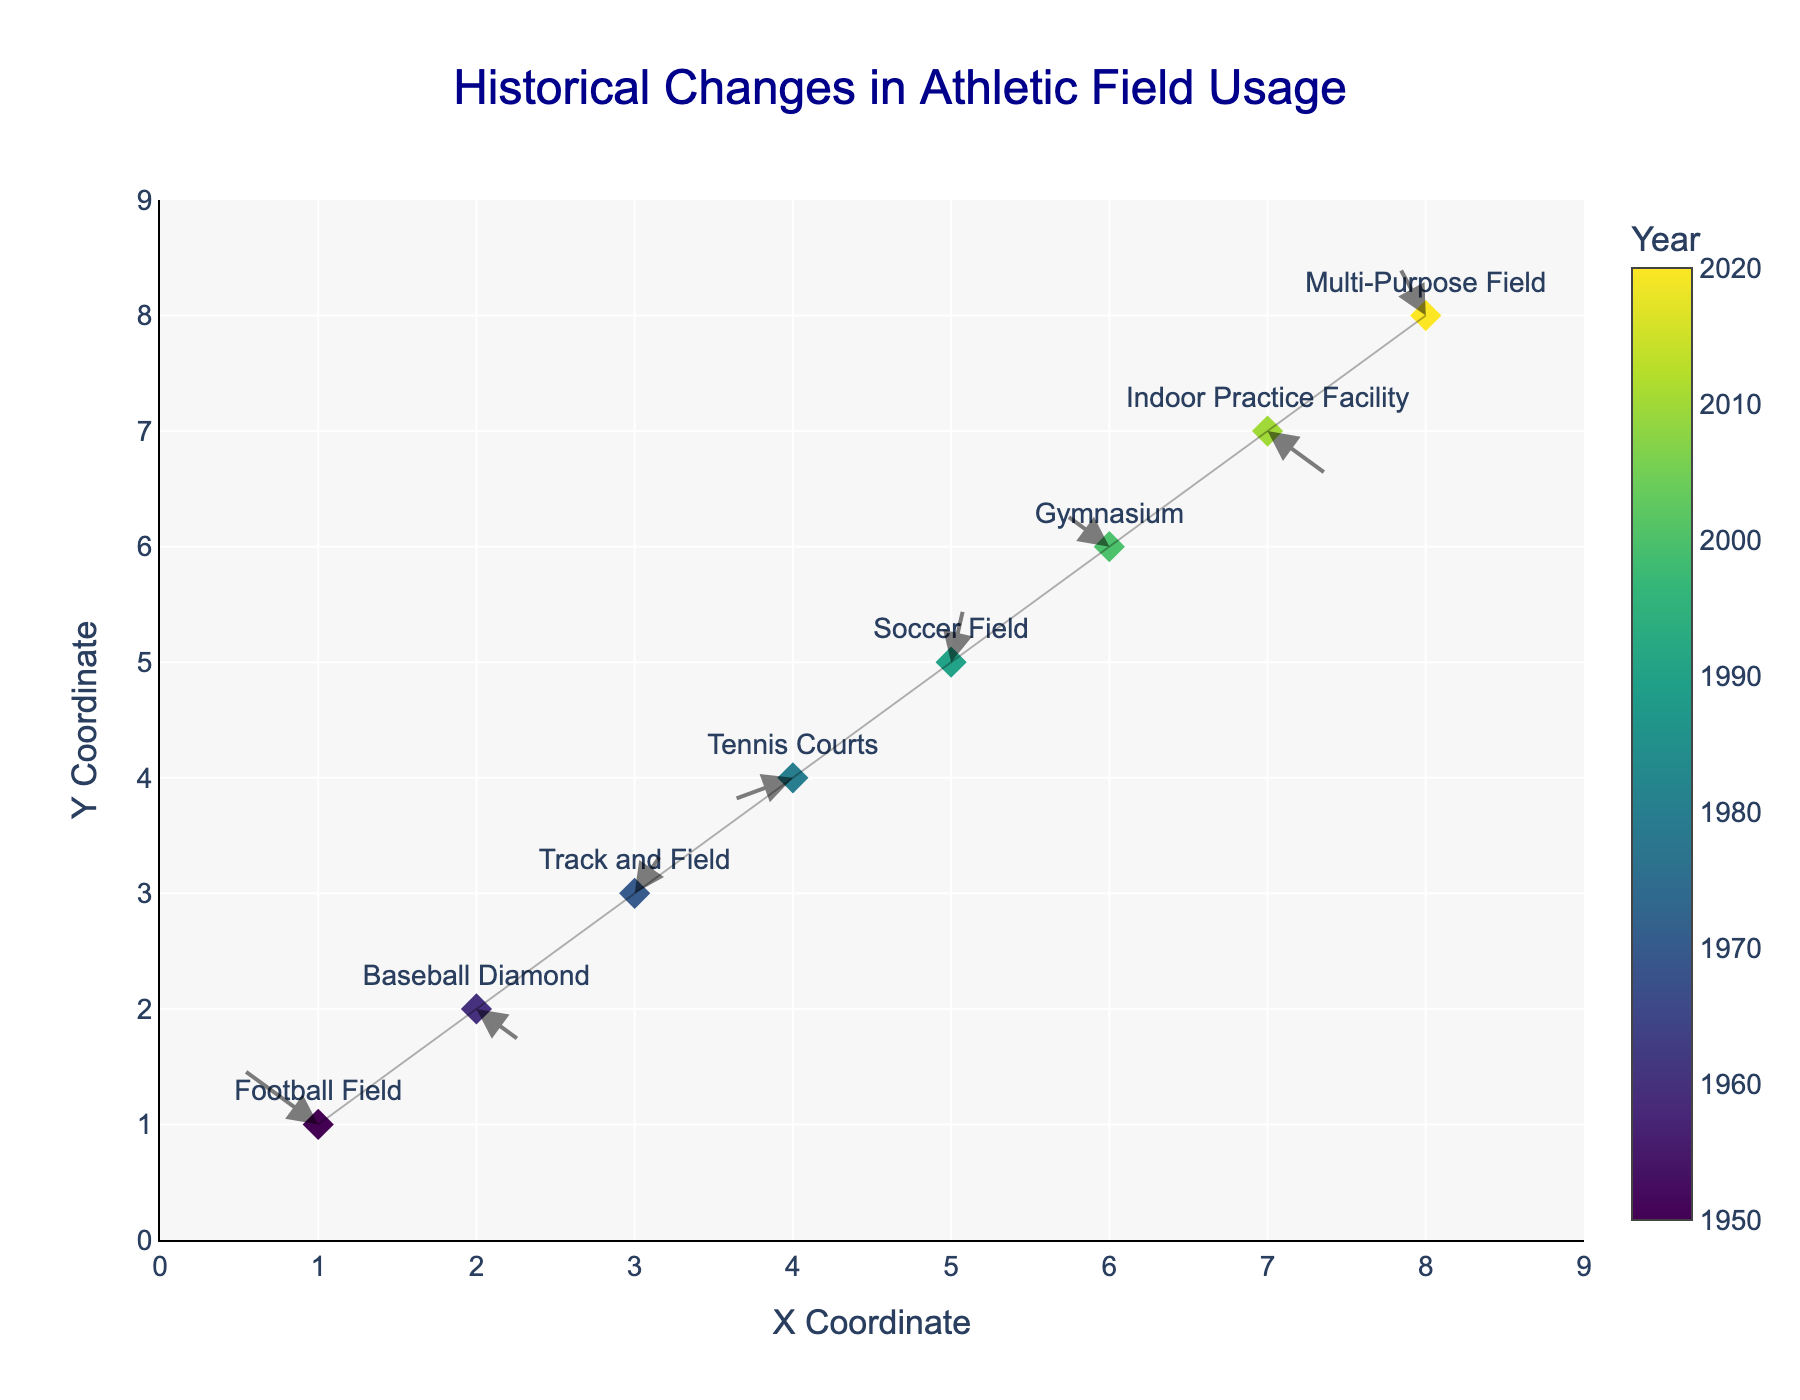What is the title of the figure? The title is usually located at the top of the figure. In this case, it describes the main theme of the chart, which is "Historical Changes in Athletic Field Usage."
Answer: Historical Changes in Athletic Field Usage How many athletic fields are represented in the figure? Each marker on the figure represents an athletic field, and there are eight such markers.
Answer: 8 In which decade did the Soccer Field have changes in its usage? By looking at the visual data indicated by the year and field name, the Soccer Field corresponds to the year 1990. Moreover, each decade's transition is marked by changes in the (U, V) vectors.
Answer: 1990 Which field had a practice change towards a positive Y direction in 1990? By analyzing the figure around the year 1990, you can see the Soccer Field's arrow (U, V) points in the positive Y direction (0.1, 0.6).
Answer: Soccer Field By how much did the Gymnasium’s practice location move in the X direction in 2000? The vector (U, V) for the Gymnasium in the year 2000 indicates its movement direction. Specifically, U = -0.3 shows a negative movement in the X direction.
Answer: -0.3 Which two fields had changes in practice location toward the negative Y direction? By observing the directions of the arrows, two fields had vectors with negative Y components: the Baseball Diamond (-0.3) in 1960 and the Indoor Practice Facility (-0.4) in 2010.
Answer: Baseball Diamond and Indoor Practice Facility What is unique about the Field movement represented in 1980 compared to others? The Tennis Courts in 1980 show a distinct movement with both U and V components negative (-0.4, -0.2), making it the only field moving downward and to the left.
Answer: Movement both downward and to the left From the figure, how can you identify the field with the largest positive change in the Y direction? The length of the arrow in the Y direction represents the magnitude of the change. The Soccer Field in 1990 has the largest positive Y component (0.6).
Answer: Soccer Field Which field saw a practice location change in the direction of (-0.5, 0.5)? By matching the (U, V) vector, the Football Field in 1950 had practice location changes that moved (-0.5, 0.5).
Answer: Football Field In which directions did the Multi-Purpose Field practices move in 2020? The vector (U, V) for the year 2020 corresponds to the Multi-Purpose Field and shows a movement of (-0.2, 0.5). This indicates a leftward and upward movement.
Answer: Leftward and upward 